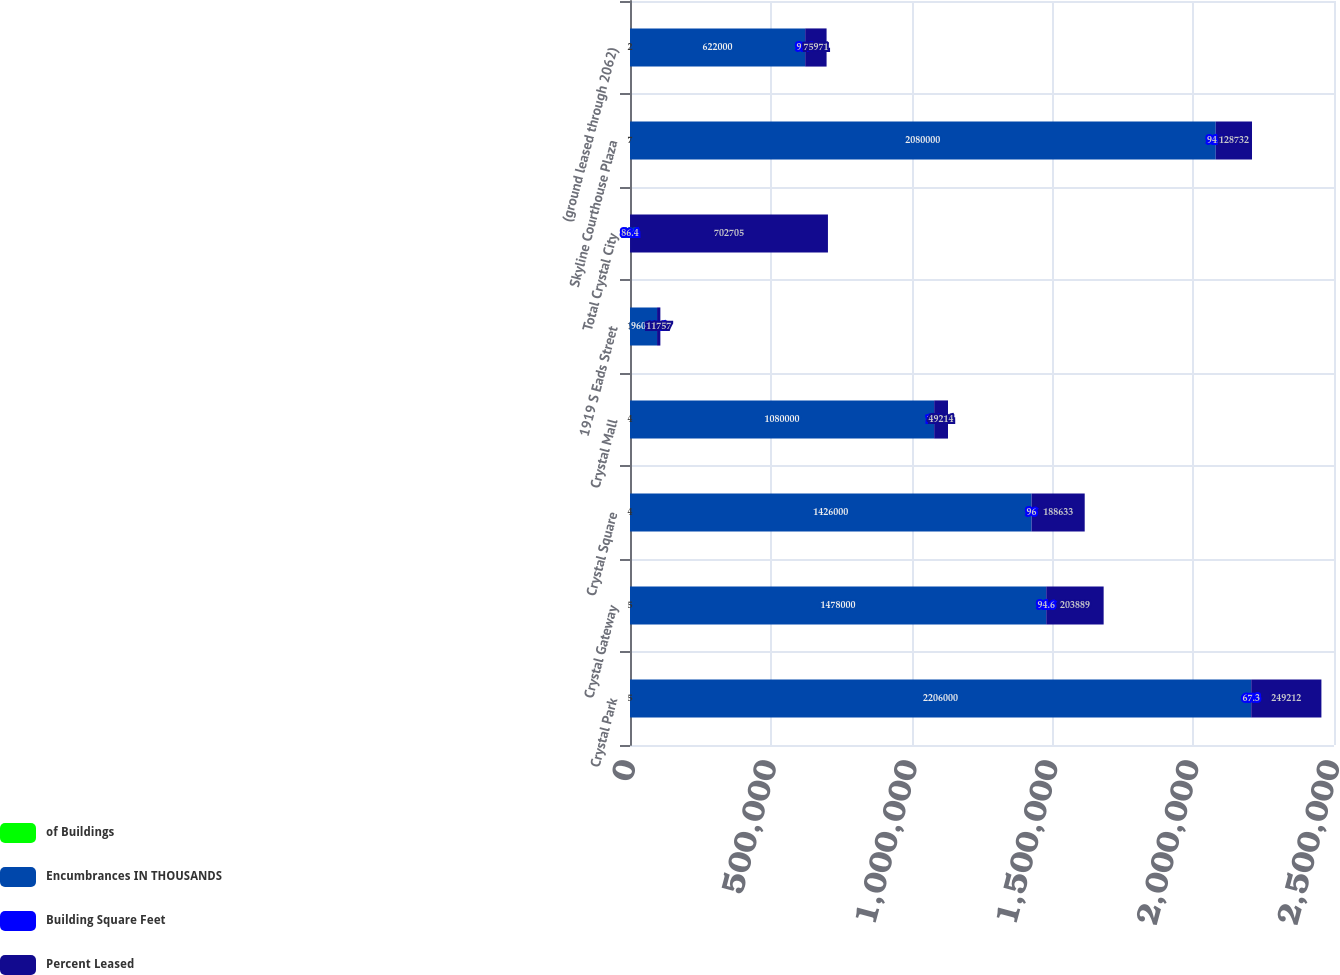<chart> <loc_0><loc_0><loc_500><loc_500><stacked_bar_chart><ecel><fcel>Crystal Park<fcel>Crystal Gateway<fcel>Crystal Square<fcel>Crystal Mall<fcel>1919 S Eads Street<fcel>Total Crystal City<fcel>Skyline Courthouse Plaza<fcel>(ground leased through 2062)<nl><fcel>of Buildings<fcel>5<fcel>5<fcel>4<fcel>4<fcel>1<fcel>28<fcel>7<fcel>2<nl><fcel>Encumbrances IN THOUSANDS<fcel>2.206e+06<fcel>1.478e+06<fcel>1.426e+06<fcel>1.08e+06<fcel>96000<fcel>100<fcel>2.08e+06<fcel>622000<nl><fcel>Building Square Feet<fcel>67.3<fcel>94.6<fcel>96<fcel>100<fcel>57.4<fcel>86.4<fcel>94.7<fcel>97.9<nl><fcel>Percent Leased<fcel>249212<fcel>203889<fcel>188633<fcel>49214<fcel>11757<fcel>702705<fcel>128732<fcel>75971<nl></chart> 